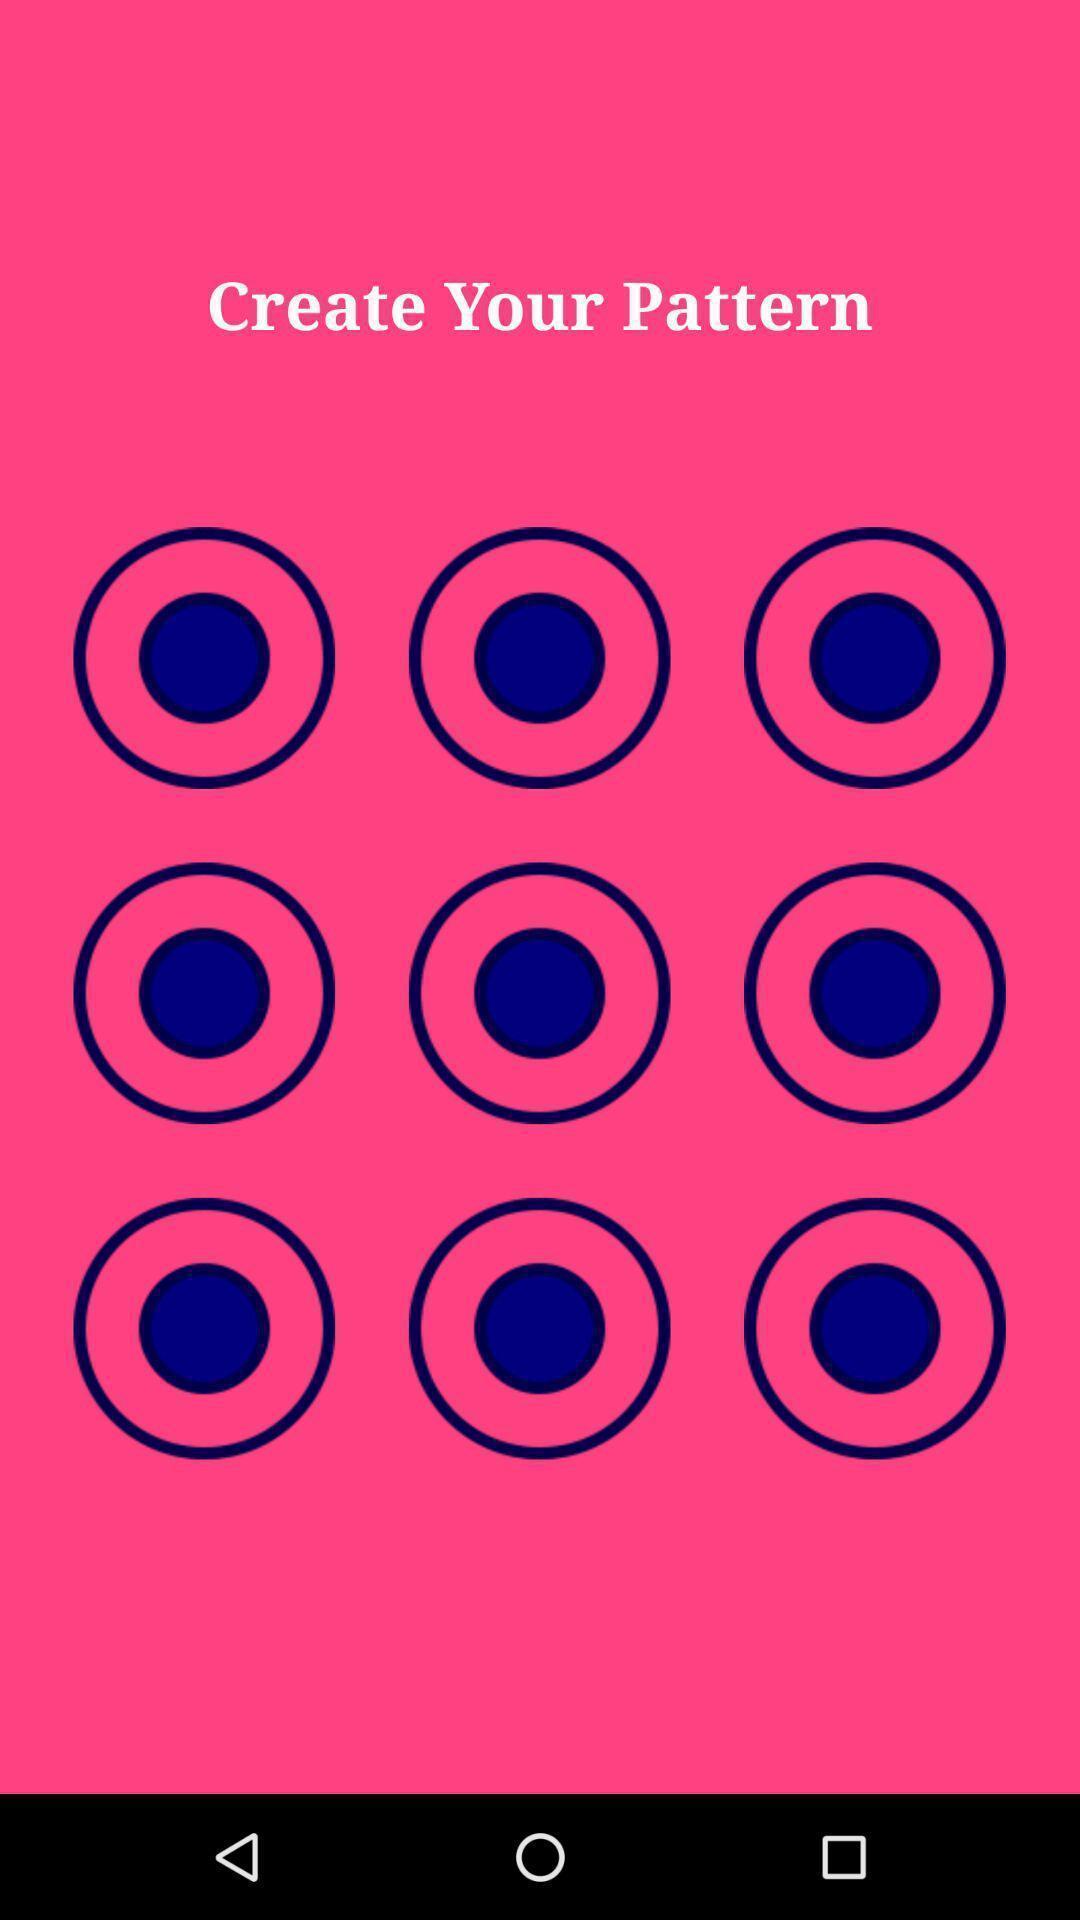What can you discern from this picture? Page to create pattern in the screen lock application. 